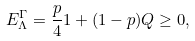Convert formula to latex. <formula><loc_0><loc_0><loc_500><loc_500>E _ { \Lambda } ^ { \Gamma } = \frac { p } { 4 } { 1 } + ( 1 - p ) Q \geq 0 ,</formula> 